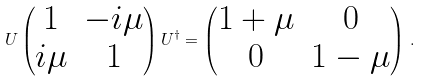Convert formula to latex. <formula><loc_0><loc_0><loc_500><loc_500>U \begin{pmatrix} 1 & - i \mu \\ i \mu & 1 \end{pmatrix} U ^ { \dagger } = \begin{pmatrix} 1 + \mu & 0 \\ 0 & 1 - \mu \end{pmatrix} \, .</formula> 